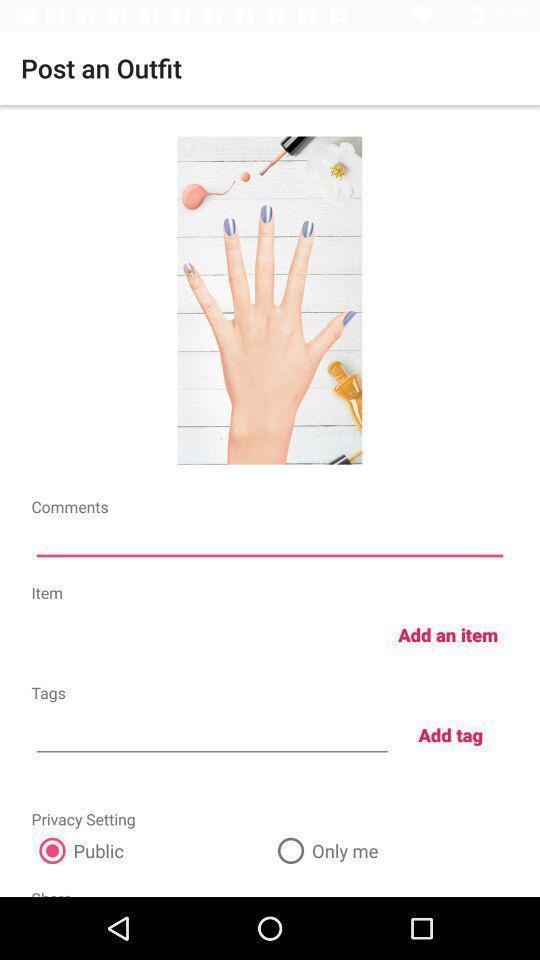Tell me what you see in this picture. Screen showing post an outfit with options. 